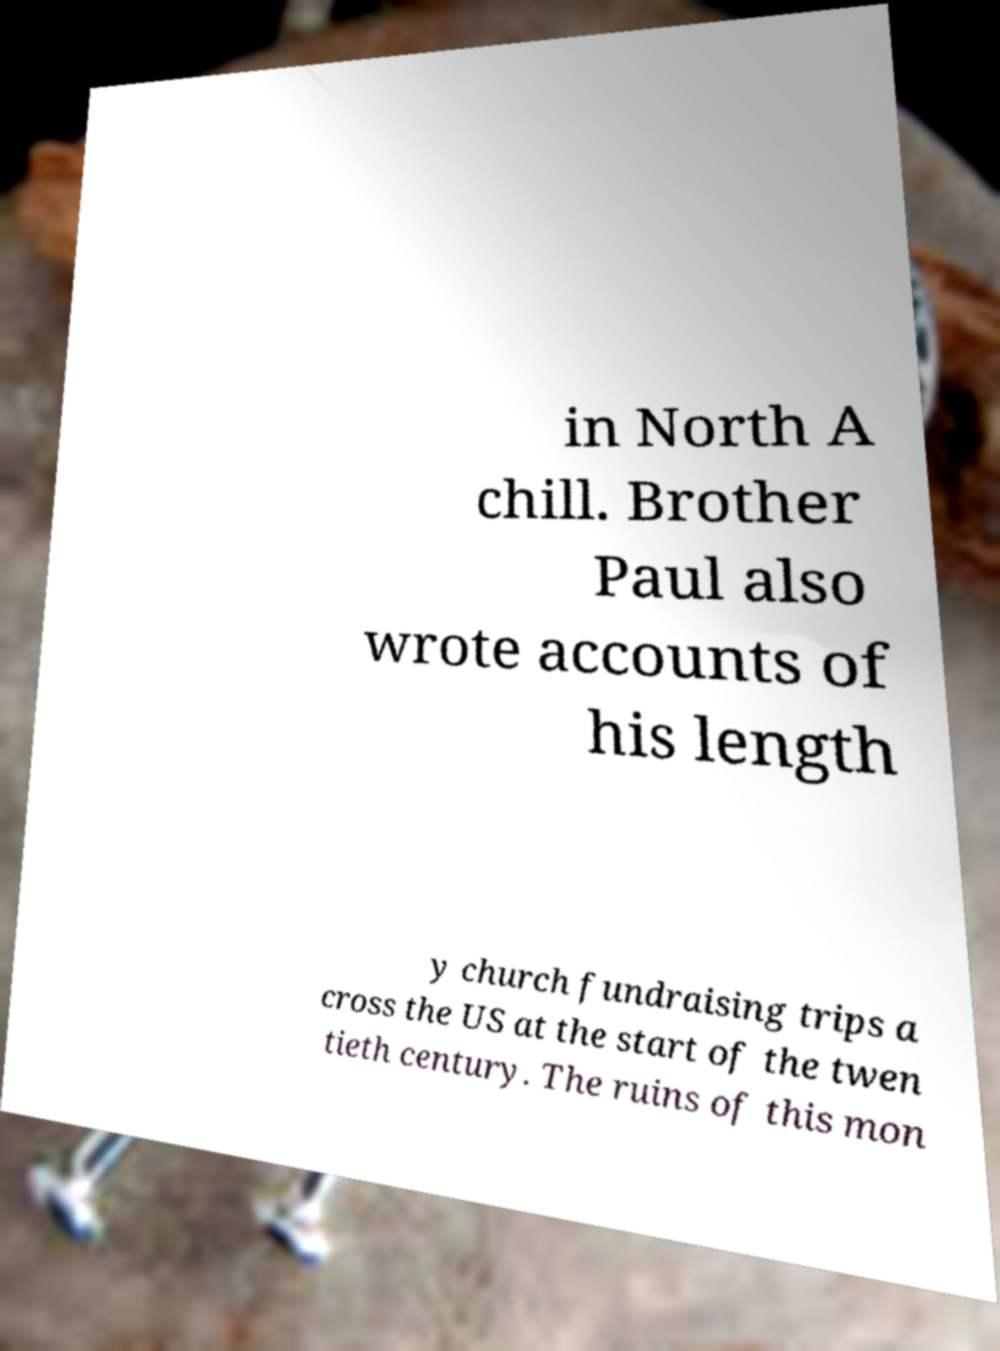There's text embedded in this image that I need extracted. Can you transcribe it verbatim? in North A chill. Brother Paul also wrote accounts of his length y church fundraising trips a cross the US at the start of the twen tieth century. The ruins of this mon 